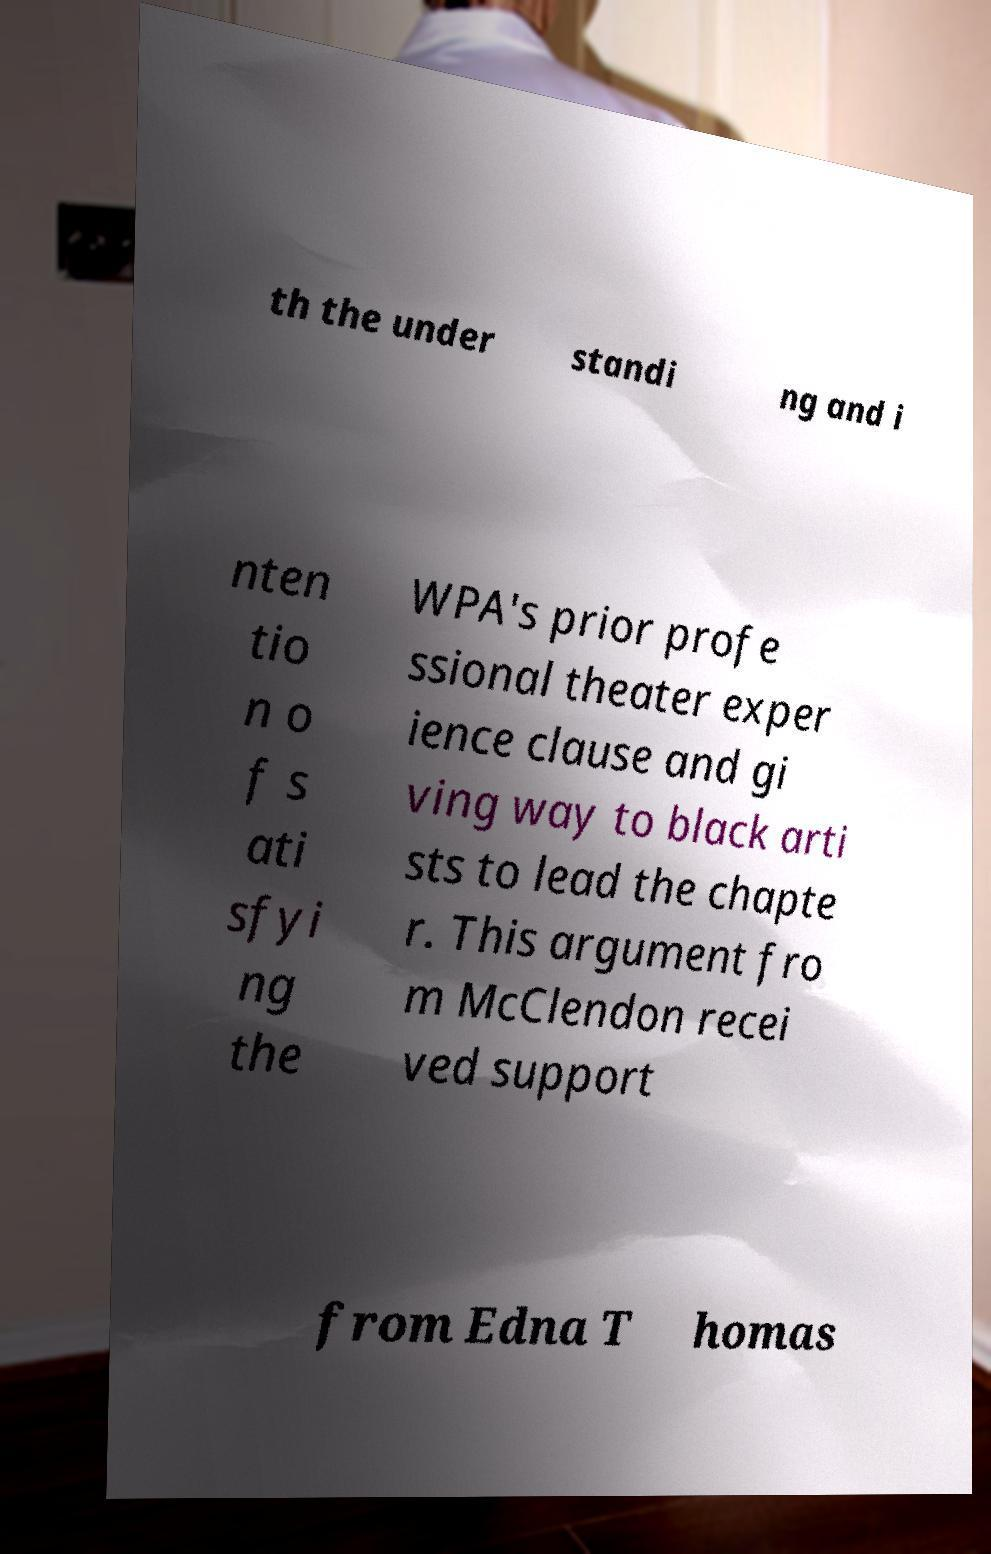There's text embedded in this image that I need extracted. Can you transcribe it verbatim? th the under standi ng and i nten tio n o f s ati sfyi ng the WPA's prior profe ssional theater exper ience clause and gi ving way to black arti sts to lead the chapte r. This argument fro m McClendon recei ved support from Edna T homas 